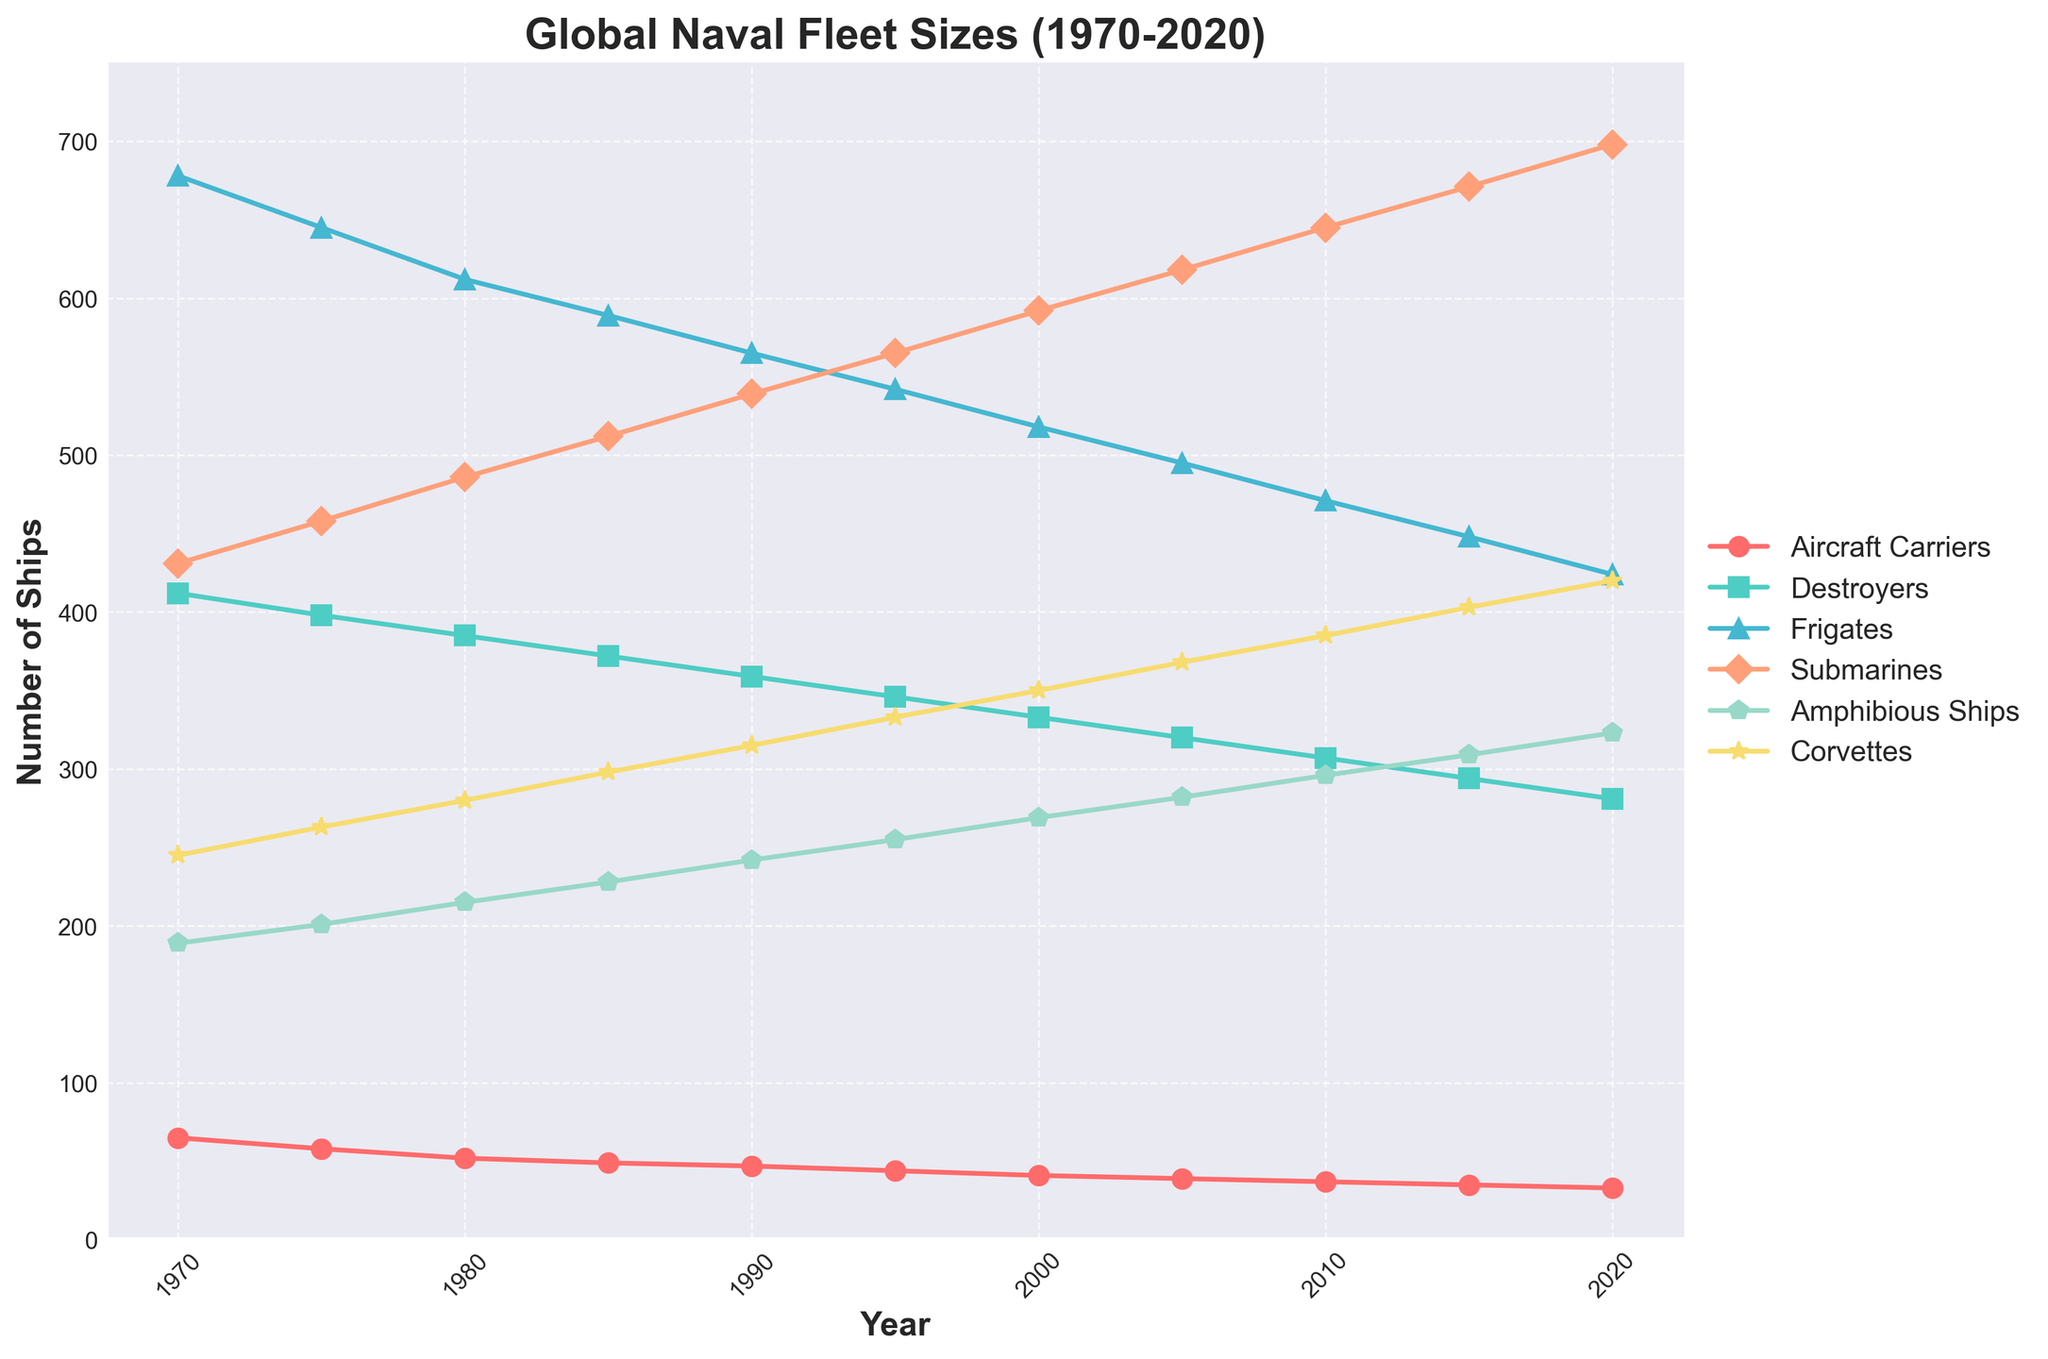How has the number of Aircraft Carriers changed over the 50 years? The number of Aircraft Carriers started at 65 in 1970 and decreased steadily to 33 in 2020. Thus, there has been a consistent decline in the number of Aircraft Carriers over the past 50 years.
Answer: Decreased Which ship type saw the highest number in 1985? Referring to the 1985 point on the chart, we see that Frigates are the tallest line, indicating they were the most numerous ship type in that year.
Answer: Frigates Between 2000 and 2020, which type of ship experienced the greatest increase in numbers? From the chart, Corvettes' line shows a clear upward trend from 2000 (350) to 2020 (420), increasing by 70, which is greater than the increase seen in other ship types in the same period.
Answer: Corvettes What is the visual difference in the trend between Submarines and Amphibious Ships from 1970 to 2020? The line for Submarines consistently rises from 431 in 1970 to 698 in 2020. Amphibious Ships also rise from 189 to 323, but at a slower rate. Thus, Submarines have a steeper upward trend compared to Amphibious Ships.
Answer: Submarines increased more steeply What is the total number of ships for all types combined in the year 1990? Summing up all types for 1990: 47 (Aircraft Carriers) + 359 (Destroyers) + 565 (Frigates) + 539 (Submarines) + 242 (Amphibious Ships) + 315 (Corvettes) = 2067
Answer: 2067 Which type of ship had the smallest decrease in numbers between 1970 and 2020? Comparing initial and final values: Aircraft Carriers decreased by 32, Destroyers by 131, Frigates by 254, Submarines increased by 267, Amphibious Ships increased by 134, and Corvettes increased by 175. The smallest decrease is seen in Aircraft Carriers (-32).
Answer: Aircraft Carriers Did the number of Frigates increase or decrease from 2010 to 2015? The number of Frigates in 2010 was 471 and decreased to 448 in 2015, showing a decline.
Answer: Decrease What was the average number of Destroyers in the 1980s? The values for the 1980s are: 385 (1980), 372 (1985), 359 (1990). The average is (385 + 372 + 359) / 3 = 1116 / 3 = 372
Answer: 372 How many more Frigates were there compared to Destroyers in 2020, and what is their percentage difference? In 2020, there were 424 Frigates and 281 Destroyers. The difference is 424 - 281 = 143. The percentage difference is (143 / 281) * 100 ≈ 50.9%
Answer: 143, 50.9% What trend in Corvettes can be observed from 1970 to 2020? The number of Corvettes began at 245 in 1970 and increased steadily to 420 in 2020, indicating a clear upward trend over the 50-year period.
Answer: Increased 